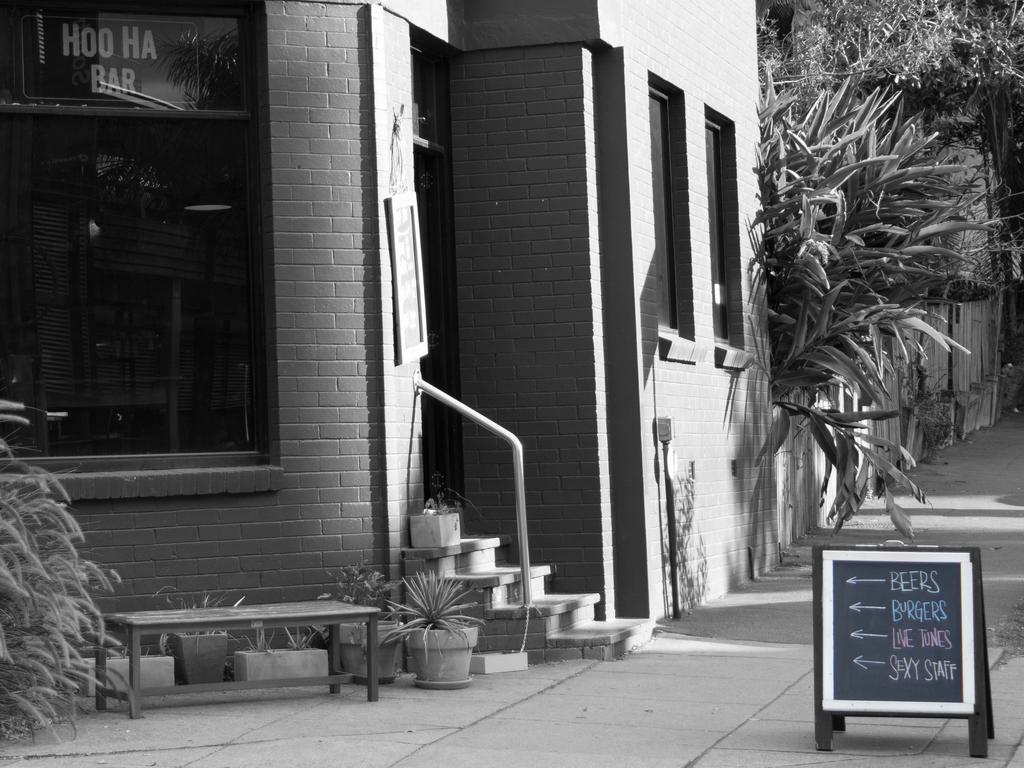In one or two sentences, can you explain what this image depicts? In this image I can see a building and at right I can see few trees and the image is in black and white, in front I can see a board and something written on it. 